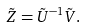<formula> <loc_0><loc_0><loc_500><loc_500>\tilde { Z } = \tilde { U } ^ { - 1 } \tilde { V } .</formula> 